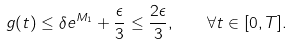<formula> <loc_0><loc_0><loc_500><loc_500>g ( t ) \leq \delta e ^ { M _ { 1 } } + \frac { \epsilon } { 3 } \leq \frac { 2 \epsilon } { 3 } , \quad \forall t \in [ 0 , T ] .</formula> 